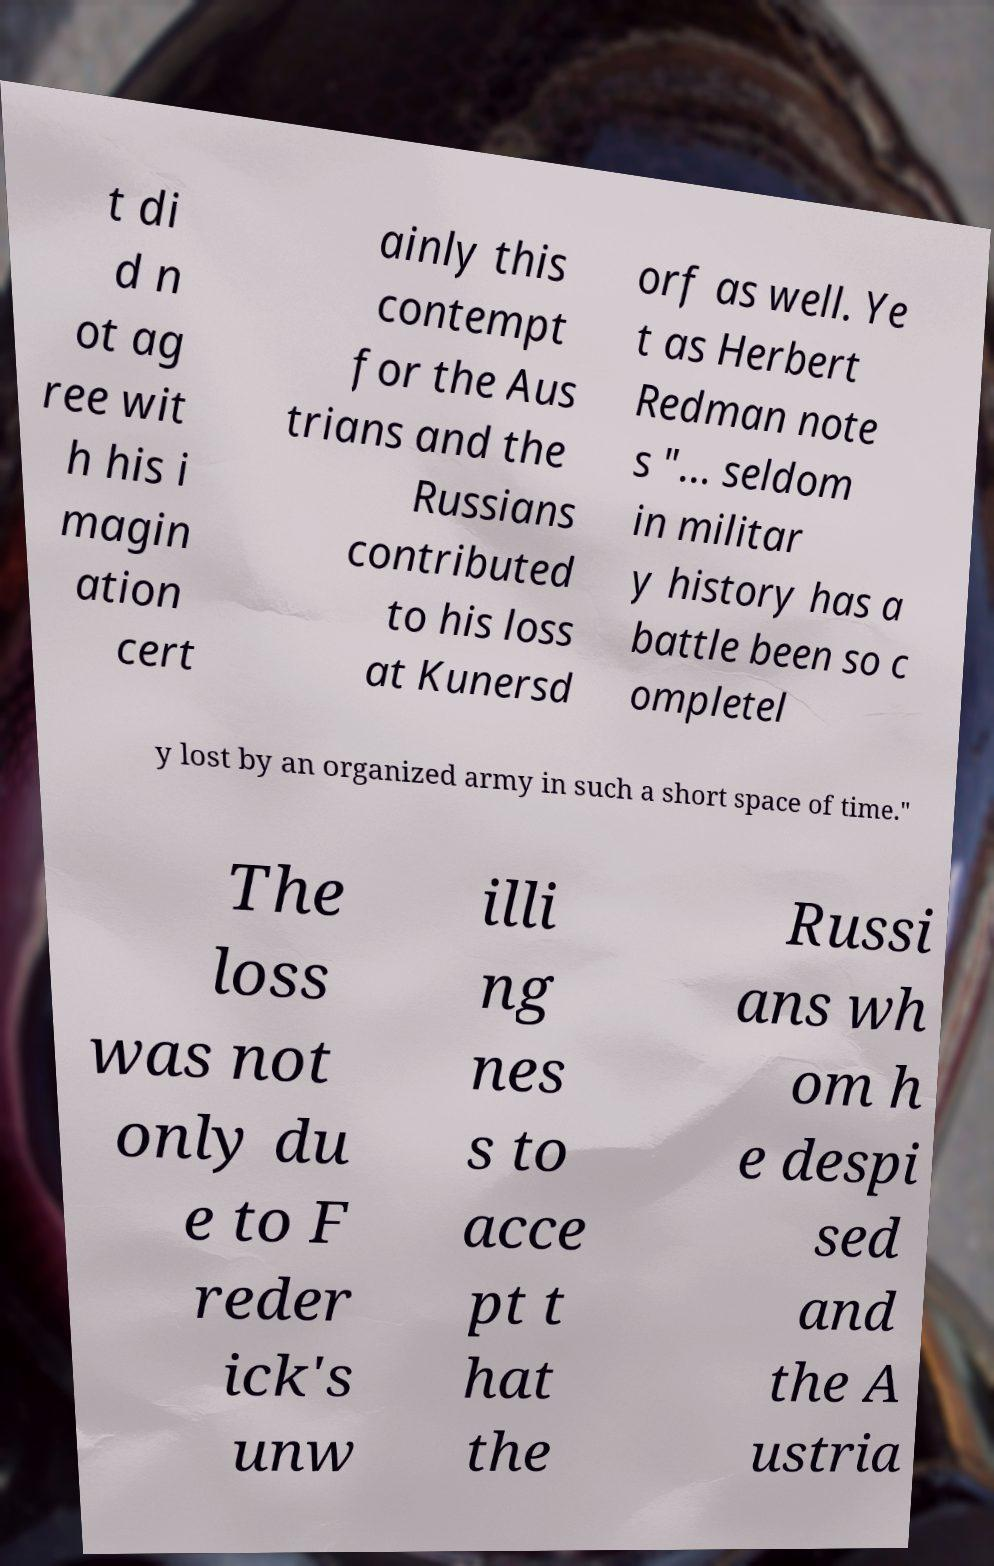I need the written content from this picture converted into text. Can you do that? t di d n ot ag ree wit h his i magin ation cert ainly this contempt for the Aus trians and the Russians contributed to his loss at Kunersd orf as well. Ye t as Herbert Redman note s "... seldom in militar y history has a battle been so c ompletel y lost by an organized army in such a short space of time." The loss was not only du e to F reder ick's unw illi ng nes s to acce pt t hat the Russi ans wh om h e despi sed and the A ustria 